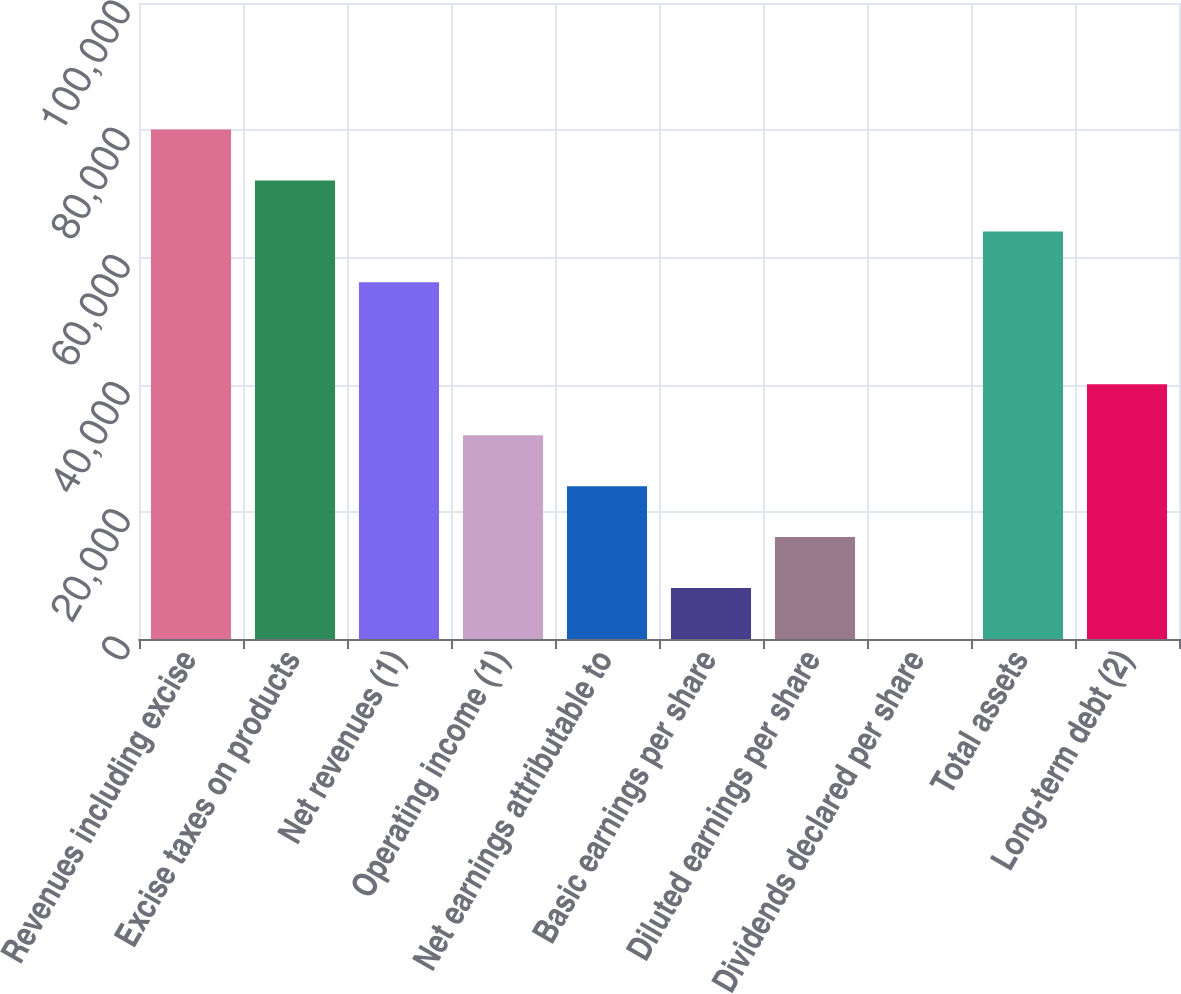<chart> <loc_0><loc_0><loc_500><loc_500><bar_chart><fcel>Revenues including excise<fcel>Excise taxes on products<fcel>Net revenues (1)<fcel>Operating income (1)<fcel>Net earnings attributable to<fcel>Basic earnings per share<fcel>Diluted earnings per share<fcel>Dividends declared per share<fcel>Total assets<fcel>Long-term debt (2)<nl><fcel>80106<fcel>72095.8<fcel>56075.3<fcel>32044.7<fcel>24034.5<fcel>8014.09<fcel>16024.3<fcel>3.88<fcel>64085.6<fcel>40054.9<nl></chart> 